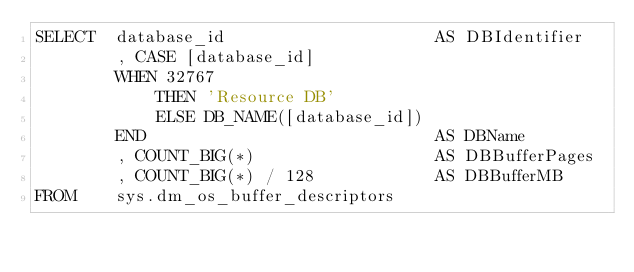Convert code to text. <code><loc_0><loc_0><loc_500><loc_500><_SQL_>SELECT  database_id                     AS DBIdentifier
        , CASE [database_id]
        WHEN 32767
            THEN 'Resource DB'
            ELSE DB_NAME([database_id])
        END                             AS DBName
        , COUNT_BIG(*)                  AS DBBufferPages
        , COUNT_BIG(*) / 128            AS DBBufferMB
FROM    sys.dm_os_buffer_descriptors</code> 